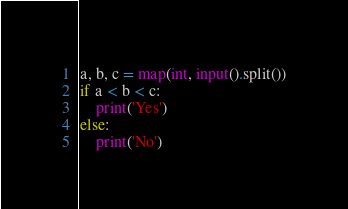Convert code to text. <code><loc_0><loc_0><loc_500><loc_500><_Python_>a, b, c = map(int, input().split())
if a < b < c:
    print('Yes')
else:
    print('No')

</code> 